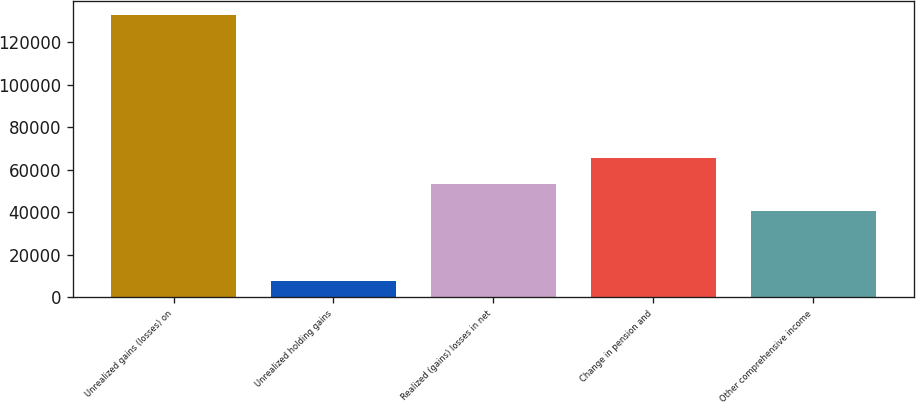Convert chart. <chart><loc_0><loc_0><loc_500><loc_500><bar_chart><fcel>Unrealized gains (losses) on<fcel>Unrealized holding gains<fcel>Realized (gains) losses in net<fcel>Change in pension and<fcel>Other comprehensive income<nl><fcel>132810<fcel>7957<fcel>53237.3<fcel>65722.6<fcel>40752<nl></chart> 